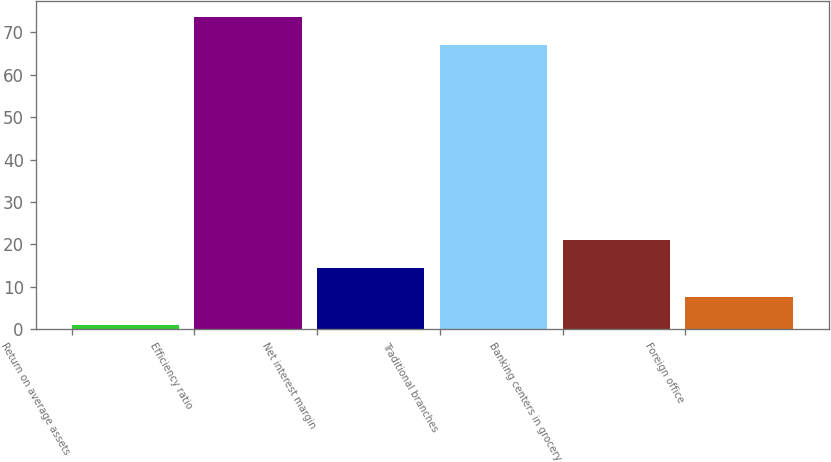Convert chart. <chart><loc_0><loc_0><loc_500><loc_500><bar_chart><fcel>Return on average assets<fcel>Efficiency ratio<fcel>Net interest margin<fcel>Traditional branches<fcel>Banking centers in grocery<fcel>Foreign office<nl><fcel>0.97<fcel>73.71<fcel>14.39<fcel>67<fcel>21.1<fcel>7.68<nl></chart> 